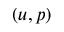<formula> <loc_0><loc_0><loc_500><loc_500>( u , p )</formula> 